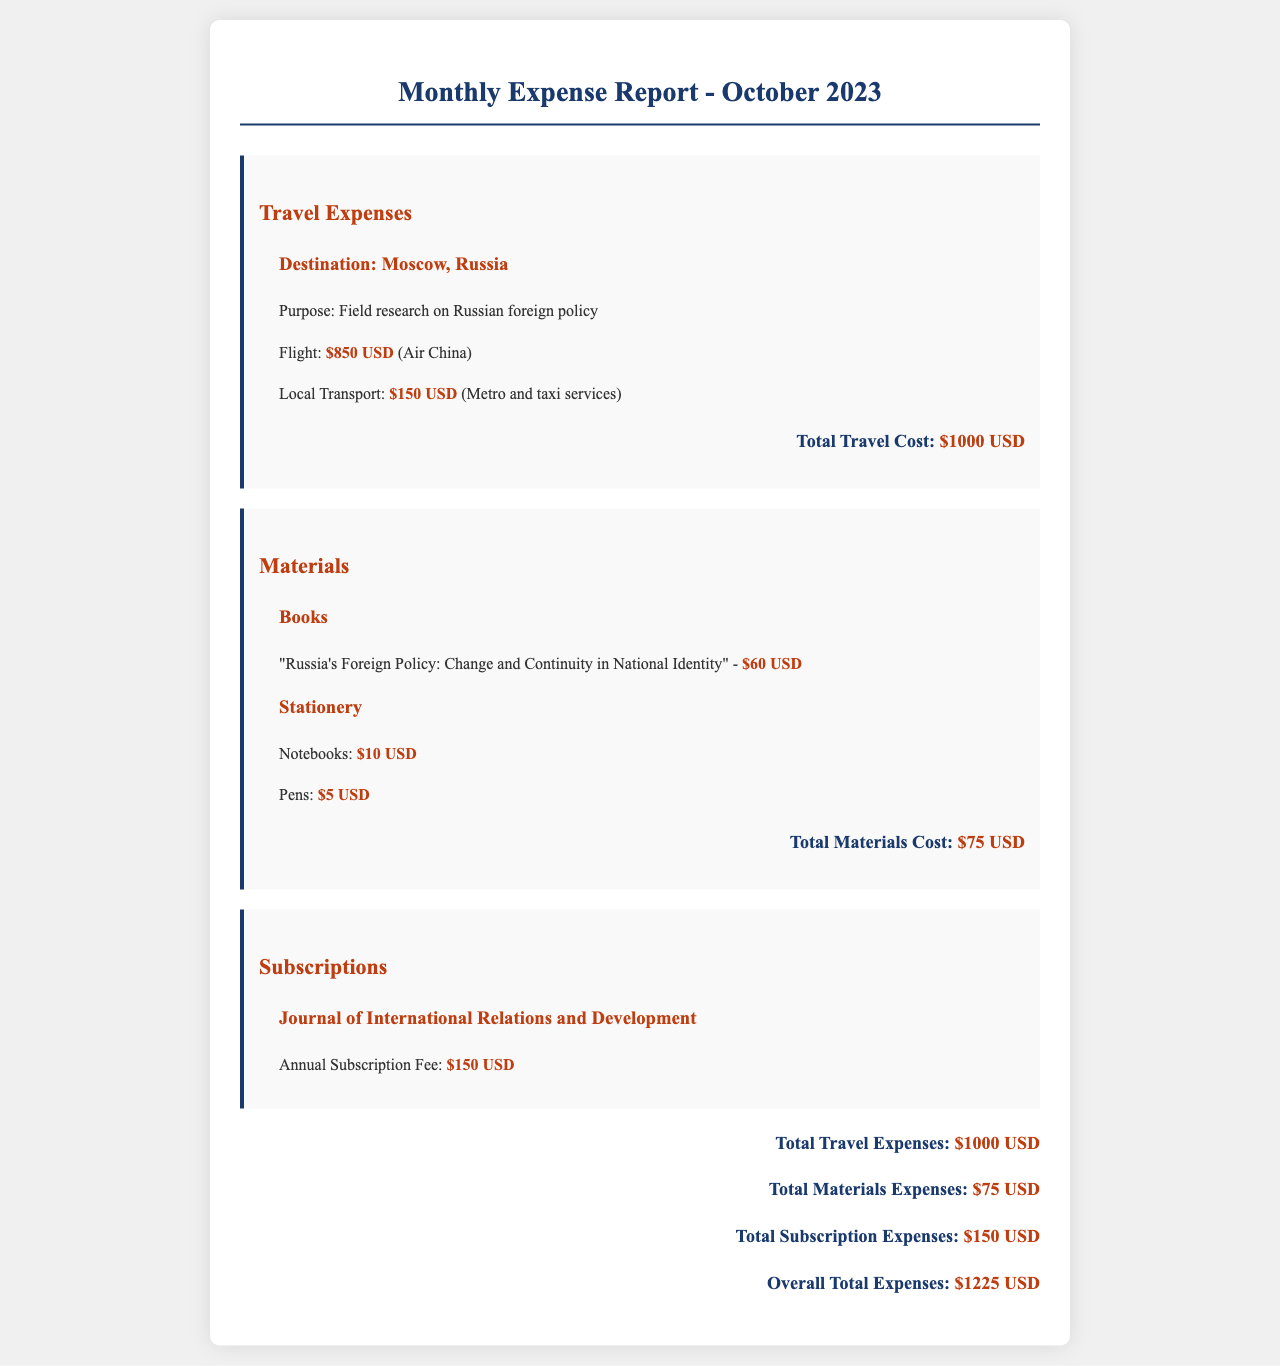what is the total travel expense? The total travel expense is detailed in the travel section of the document and includes the cost of the flight and local transport.
Answer: $1000 USD how much was spent on books? The amount spent on books is mentioned under the Materials section, specifying the price of the individual books.
Answer: $60 USD what is the annual subscription fee for the journal? The annual subscription fee for the journal is stated in the Subscriptions section, outlining the cost incurred for accessing the publication.
Answer: $150 USD how much was spent on stationery? The total amount for stationery can be found among the listed expenses under Materials, detailing each item's price.
Answer: $15 USD what is the overall total expense for the month? The overall total expense is the sum of travel, materials, and subscription expenses, represented at the end of the document.
Answer: $1225 USD what was the purpose of the travel to Moscow? The purpose of travel is explicitly mentioned in the travel expense section of the document, highlighting the focus of the research.
Answer: Field research on Russian foreign policy how much was spent on local transport? The local transport cost is listed within the travel expenses section, providing a clear breakdown of travel costs.
Answer: $150 USD what book is mentioned in the materials section? A specific title of a book related to the research topic is indicated in the materials section, along with its price.
Answer: "Russia's Foreign Policy: Change and Continuity in National Identity" 